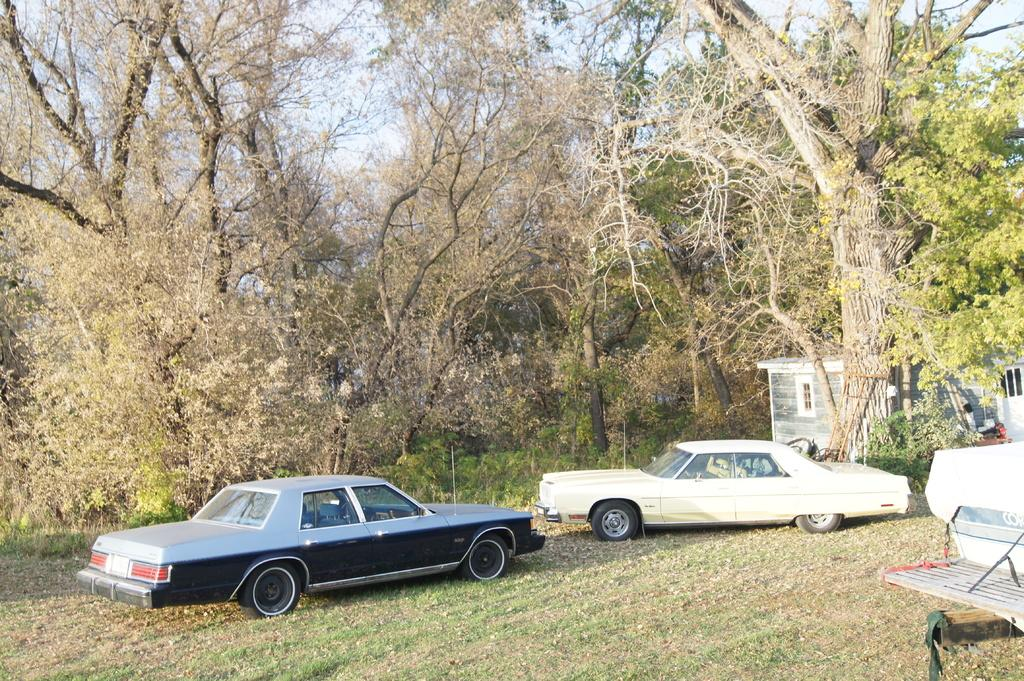What type of vehicles can be seen in the image? There are cars in the image. What is located on the right side of the image? There is an object on the right side of the image. What structures are present in the image? There are buildings in the image. What type of natural elements can be seen in the background of the image? There are trees in the background of the image. What is visible in the sky in the background of the image? The sky is visible in the background of the image. What type of birds can be seen flying in a group in the image? There are no birds visible in the image. Is there a horse present in the image? No, there is no horse present in the image. 